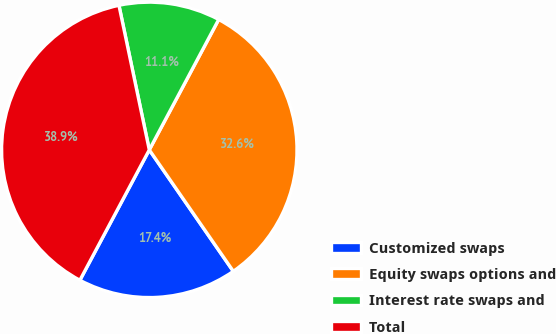<chart> <loc_0><loc_0><loc_500><loc_500><pie_chart><fcel>Customized swaps<fcel>Equity swaps options and<fcel>Interest rate swaps and<fcel>Total<nl><fcel>17.42%<fcel>32.58%<fcel>11.08%<fcel>38.92%<nl></chart> 